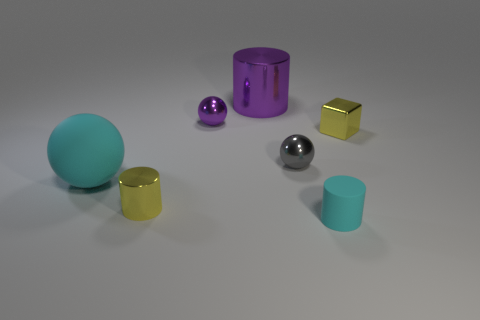There is a purple cylinder that is made of the same material as the cube; what size is it?
Provide a short and direct response. Large. Are there fewer tiny cyan rubber things than cylinders?
Provide a succinct answer. Yes. There is a gray ball that is the same size as the purple metal ball; what material is it?
Your response must be concise. Metal. Is the number of purple metal spheres greater than the number of cyan rubber objects?
Give a very brief answer. No. What number of other objects are the same color as the rubber cylinder?
Provide a succinct answer. 1. How many tiny objects are on the left side of the tiny cyan matte cylinder and behind the gray sphere?
Give a very brief answer. 1. Are there more small objects that are on the left side of the small block than tiny yellow things right of the purple shiny cylinder?
Offer a terse response. Yes. What material is the cyan object that is in front of the big cyan matte ball?
Your answer should be very brief. Rubber. Do the small cyan rubber object and the yellow object that is on the left side of the big cylinder have the same shape?
Your response must be concise. Yes. How many small yellow metal cylinders are in front of the small yellow metal thing that is on the left side of the cylinder behind the metallic cube?
Keep it short and to the point. 0. 